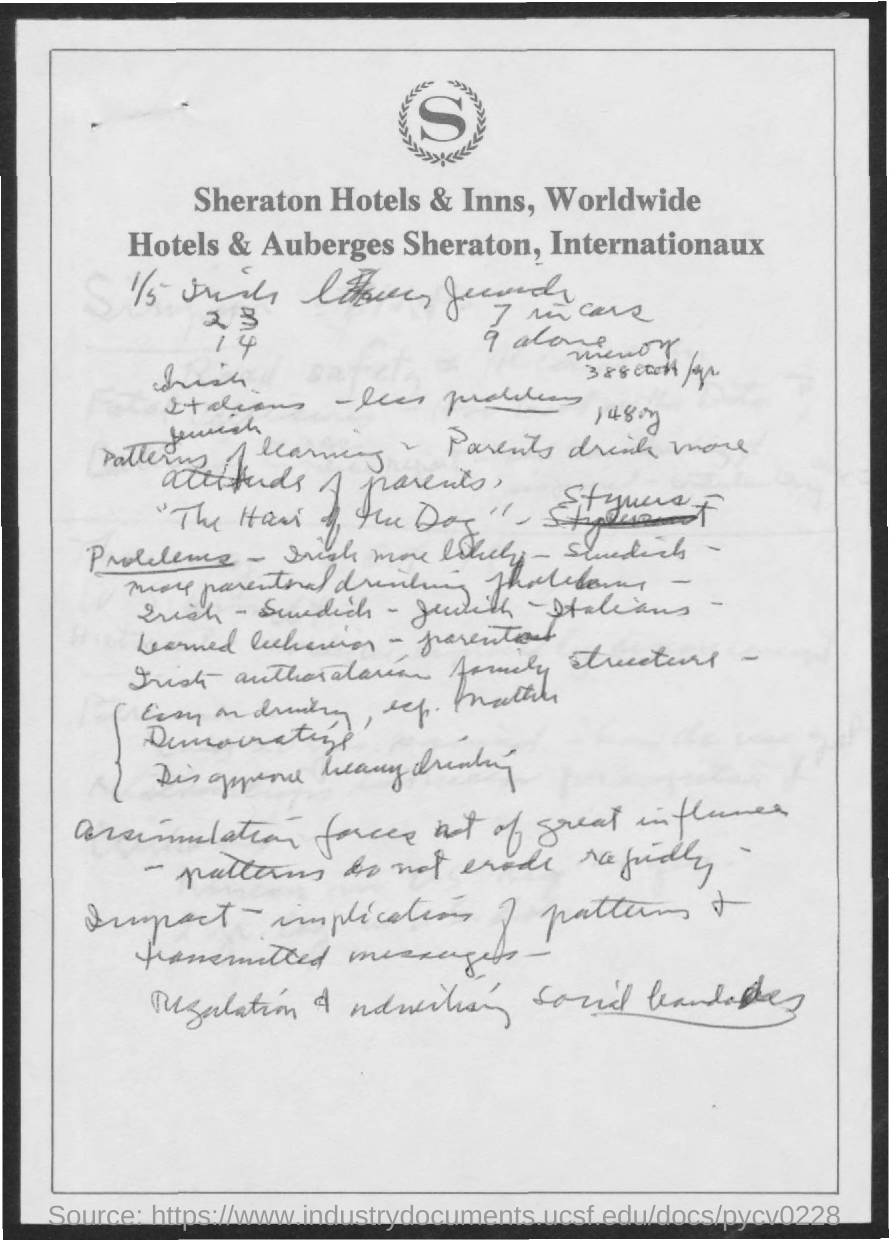Outline some significant characteristics in this image. The letterhead in question is from a chain of hotels called Sheraton. 